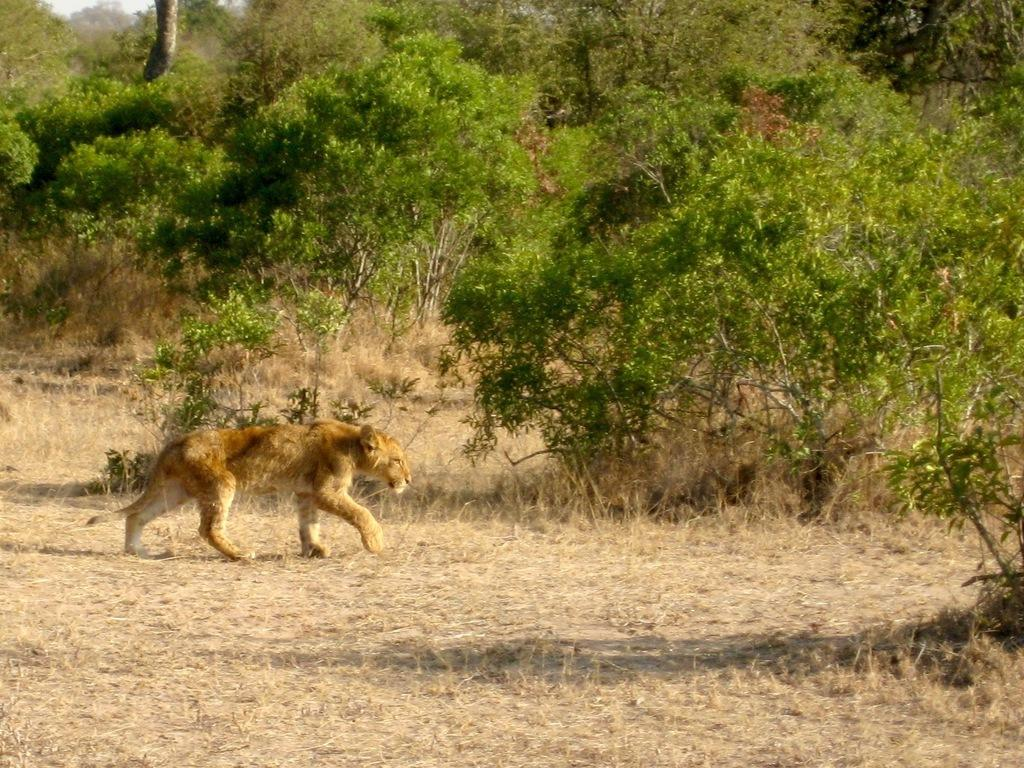What animal is the main subject of the image? There is a tiger in the image. What is the tiger doing in the image? The tiger is walking on grass. What type of environment is visible in the image? There are trees visible in the image. What type of servant can be seen attending to the tiger in the image? There is no servant present in the image; it only features a tiger walking on grass. How many ducks are visible in the image? There are no ducks present in the image; it only features a tiger walking on grass. 